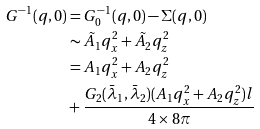<formula> <loc_0><loc_0><loc_500><loc_500>G ^ { - 1 } ( { q } , 0 ) & = G _ { 0 } ^ { - 1 } ( { q } , 0 ) - \Sigma ( { q } , 0 ) \\ & \sim \tilde { A _ { 1 } } q _ { x } ^ { 2 } + \tilde { A _ { 2 } } q _ { z } ^ { 2 } \\ & = A _ { 1 } q _ { x } ^ { 2 } + A _ { 2 } q _ { z } ^ { 2 } \\ & + \frac { G _ { 2 } ( \bar { \lambda } _ { 1 } , \bar { \lambda } _ { 2 } ) ( A _ { 1 } q _ { x } ^ { 2 } + A _ { 2 } q _ { z } ^ { 2 } ) l } { 4 \times 8 \pi }</formula> 